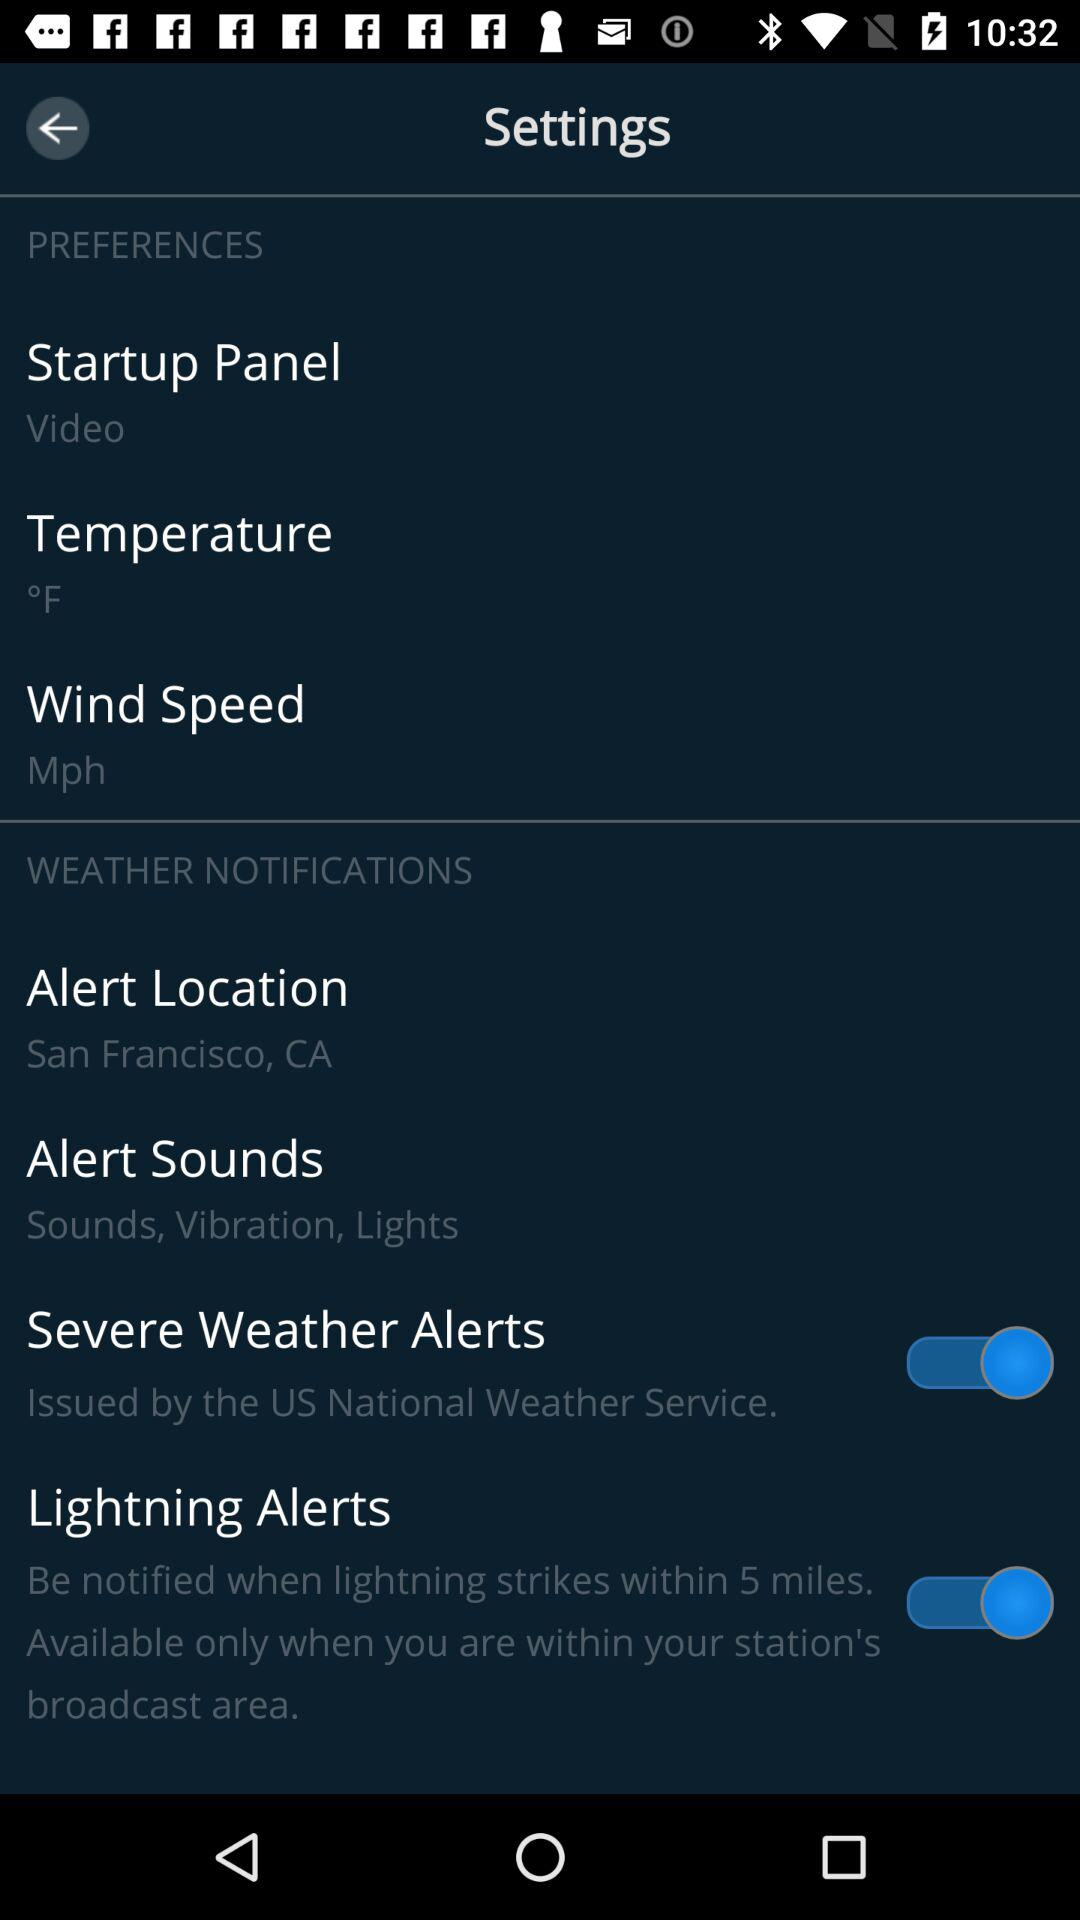What is the status of the "Lightning Alerts"? The status is "on". 